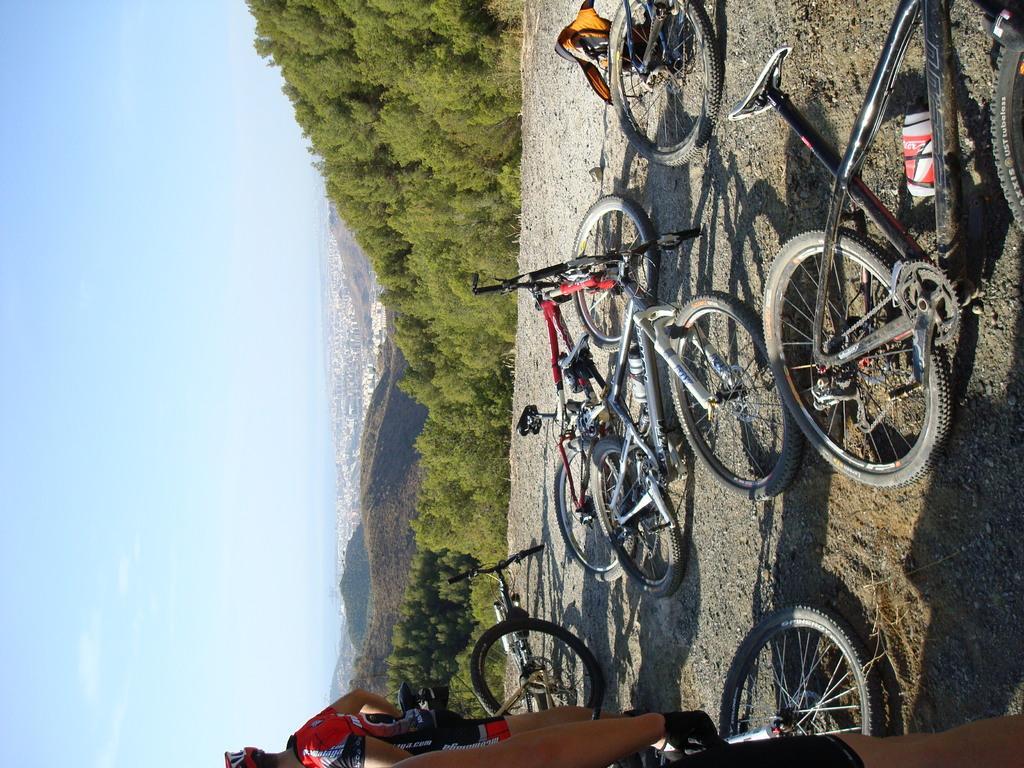Could you give a brief overview of what you see in this image? In the center of the image there are bicycles. At the bottom there are people. In the background there are hills, trees and sky. 